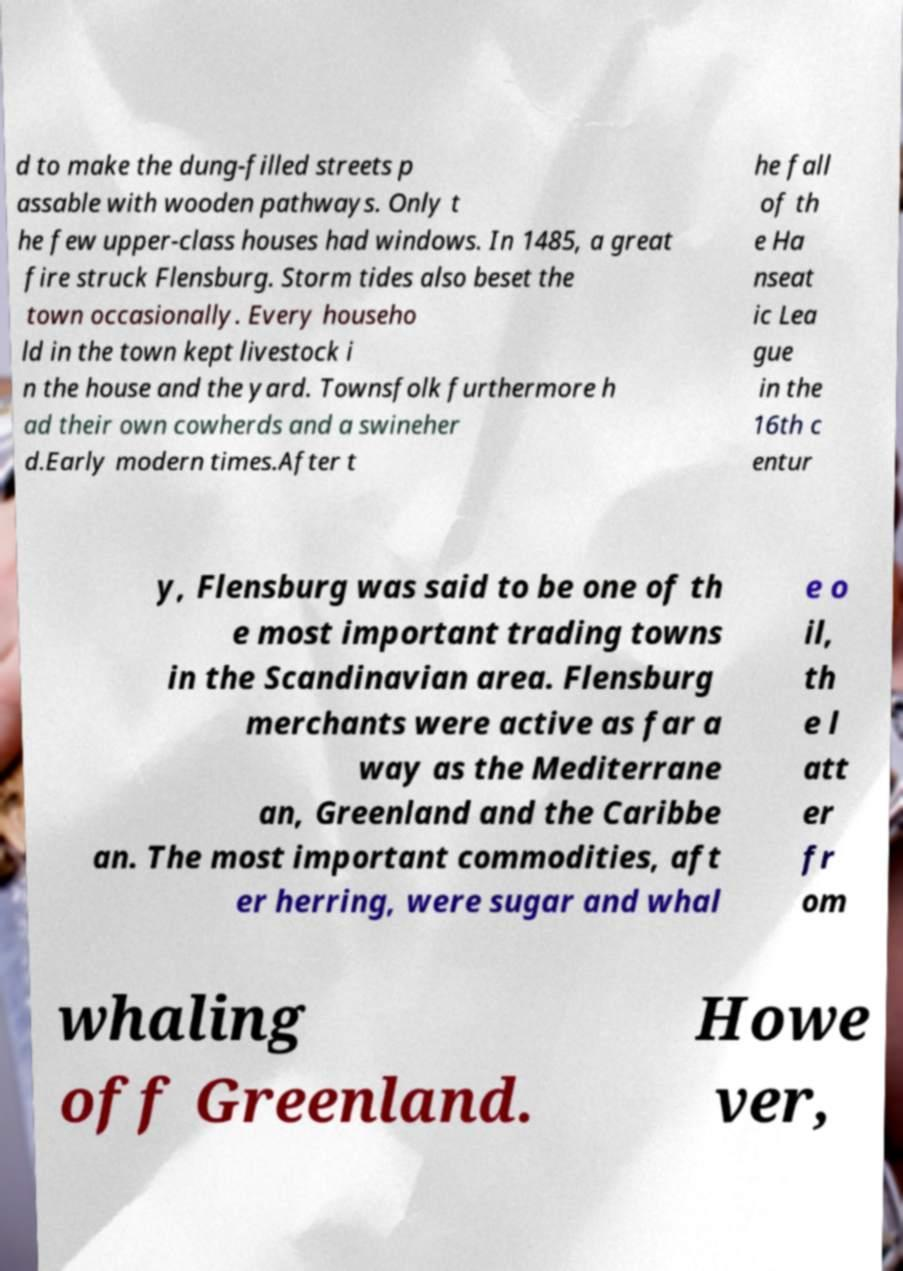Can you accurately transcribe the text from the provided image for me? d to make the dung-filled streets p assable with wooden pathways. Only t he few upper-class houses had windows. In 1485, a great fire struck Flensburg. Storm tides also beset the town occasionally. Every househo ld in the town kept livestock i n the house and the yard. Townsfolk furthermore h ad their own cowherds and a swineher d.Early modern times.After t he fall of th e Ha nseat ic Lea gue in the 16th c entur y, Flensburg was said to be one of th e most important trading towns in the Scandinavian area. Flensburg merchants were active as far a way as the Mediterrane an, Greenland and the Caribbe an. The most important commodities, aft er herring, were sugar and whal e o il, th e l att er fr om whaling off Greenland. Howe ver, 